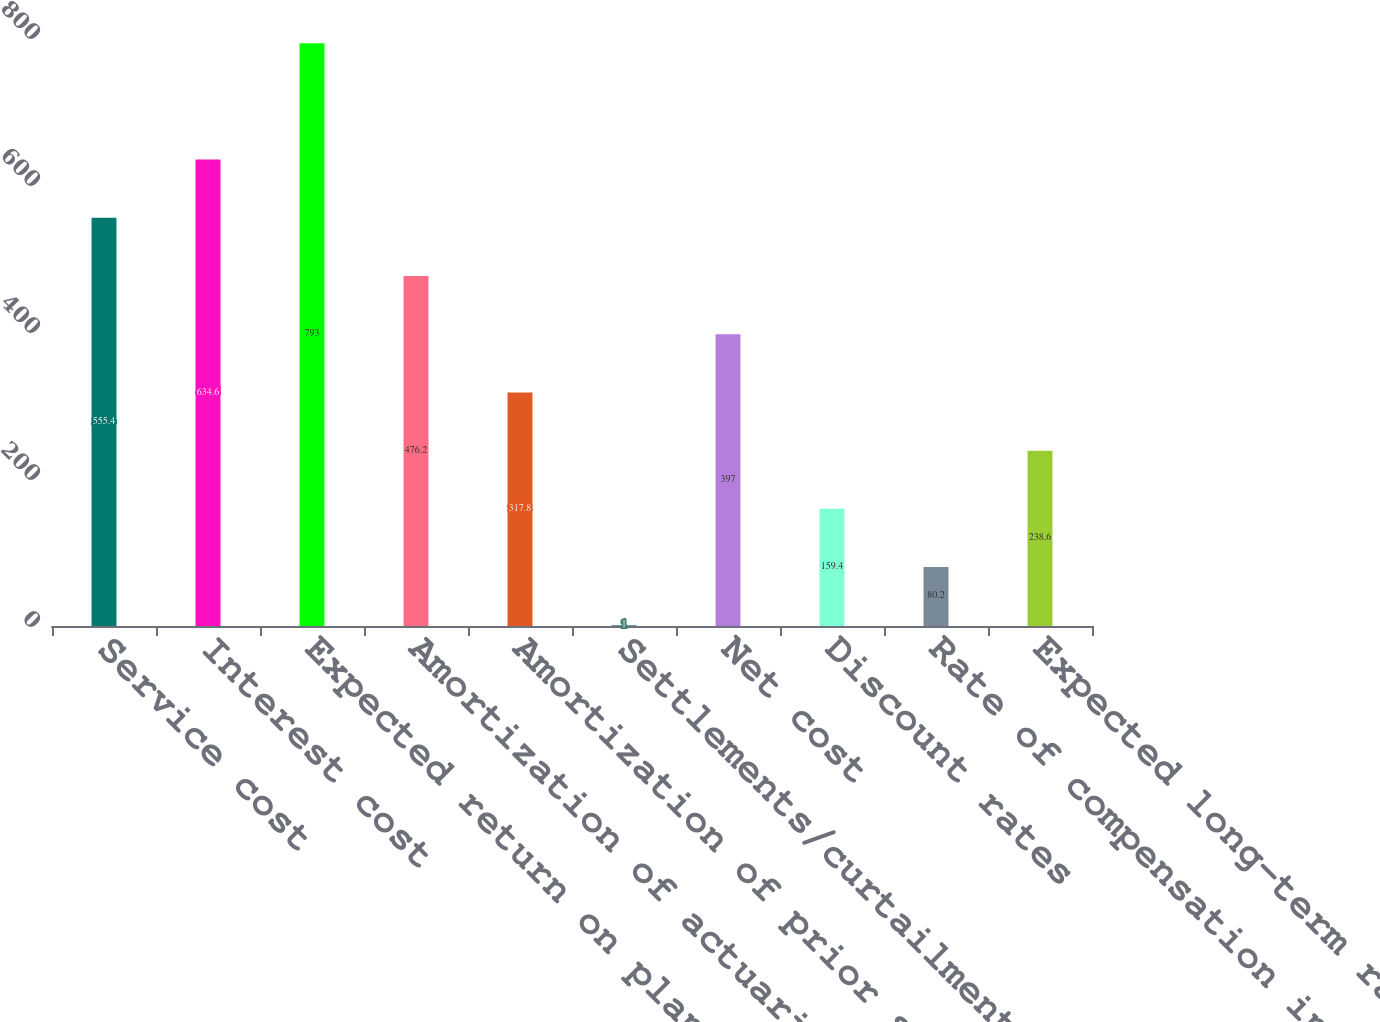Convert chart. <chart><loc_0><loc_0><loc_500><loc_500><bar_chart><fcel>Service cost<fcel>Interest cost<fcel>Expected return on plan assets<fcel>Amortization of actuarial<fcel>Amortization of prior service<fcel>Settlements/curtailments<fcel>Net cost<fcel>Discount rates<fcel>Rate of compensation increase<fcel>Expected long-term rates of<nl><fcel>555.4<fcel>634.6<fcel>793<fcel>476.2<fcel>317.8<fcel>1<fcel>397<fcel>159.4<fcel>80.2<fcel>238.6<nl></chart> 